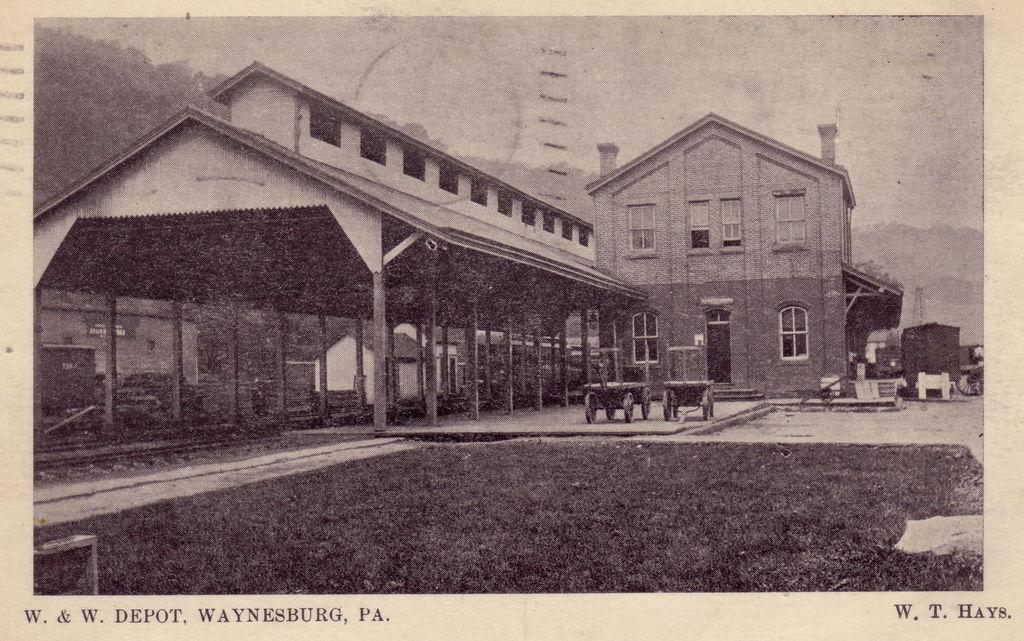Please provide a concise description of this image. In the picture we can see a photograph in that we can see a historical building and a shed near to it with a pillar and a some carts on the path and in the background we can see hills and a sky. 